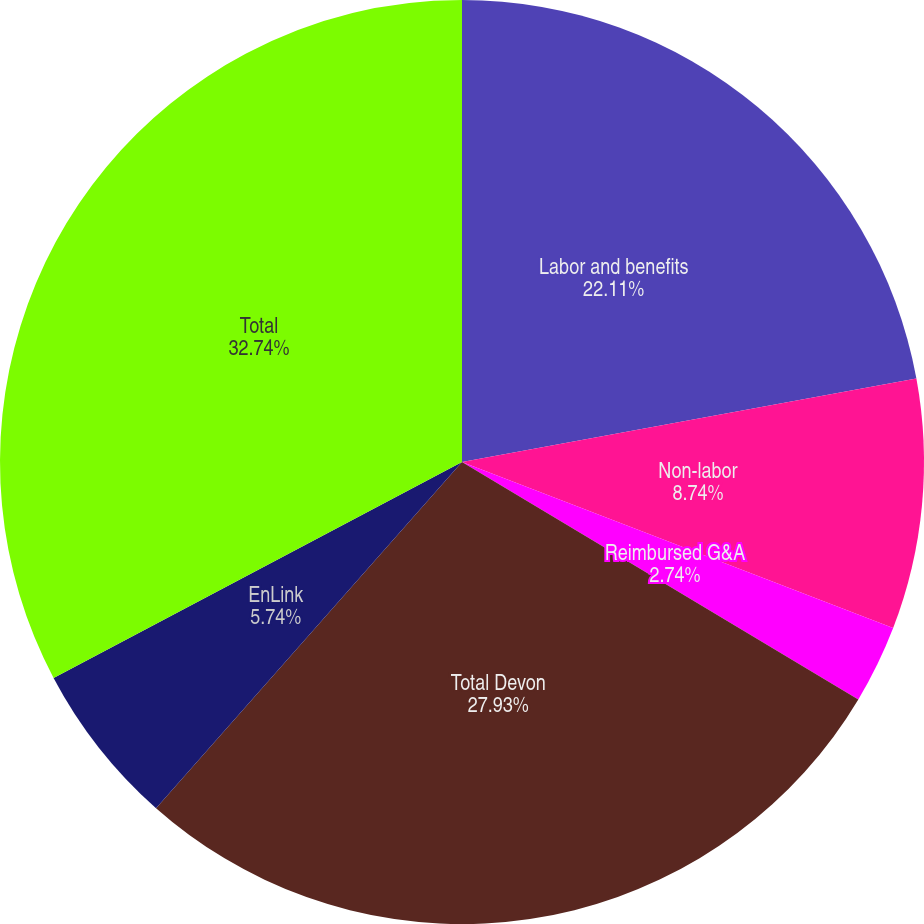<chart> <loc_0><loc_0><loc_500><loc_500><pie_chart><fcel>Labor and benefits<fcel>Non-labor<fcel>Reimbursed G&A<fcel>Total Devon<fcel>EnLink<fcel>Total<nl><fcel>22.11%<fcel>8.74%<fcel>2.74%<fcel>27.93%<fcel>5.74%<fcel>32.74%<nl></chart> 